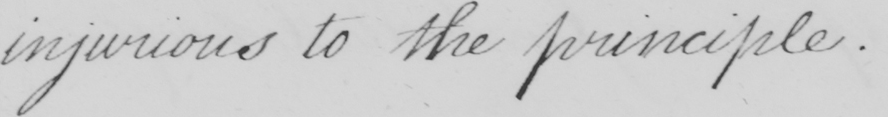What is written in this line of handwriting? injurious to the principle . 